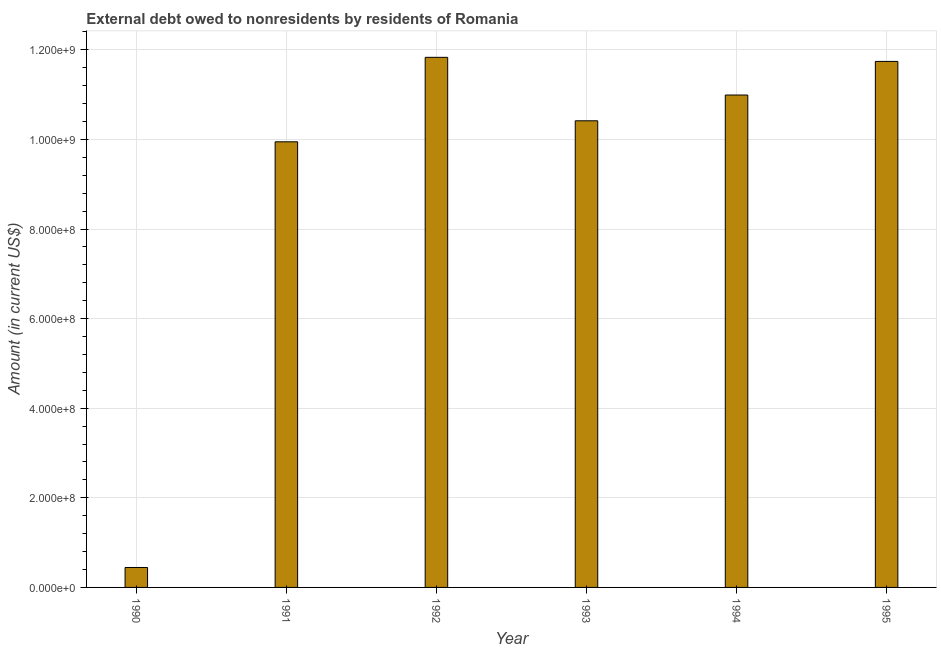Does the graph contain any zero values?
Ensure brevity in your answer.  No. What is the title of the graph?
Make the answer very short. External debt owed to nonresidents by residents of Romania. What is the label or title of the X-axis?
Provide a succinct answer. Year. What is the label or title of the Y-axis?
Keep it short and to the point. Amount (in current US$). What is the debt in 1992?
Offer a very short reply. 1.18e+09. Across all years, what is the maximum debt?
Make the answer very short. 1.18e+09. Across all years, what is the minimum debt?
Your answer should be compact. 4.45e+07. In which year was the debt minimum?
Offer a very short reply. 1990. What is the sum of the debt?
Offer a terse response. 5.54e+09. What is the difference between the debt in 1991 and 1995?
Provide a short and direct response. -1.79e+08. What is the average debt per year?
Ensure brevity in your answer.  9.23e+08. What is the median debt?
Keep it short and to the point. 1.07e+09. Do a majority of the years between 1992 and 1995 (inclusive) have debt greater than 280000000 US$?
Provide a short and direct response. Yes. What is the ratio of the debt in 1994 to that in 1995?
Your answer should be compact. 0.94. What is the difference between the highest and the second highest debt?
Give a very brief answer. 9.10e+06. Is the sum of the debt in 1990 and 1992 greater than the maximum debt across all years?
Make the answer very short. Yes. What is the difference between the highest and the lowest debt?
Keep it short and to the point. 1.14e+09. In how many years, is the debt greater than the average debt taken over all years?
Your response must be concise. 5. How many bars are there?
Make the answer very short. 6. Are all the bars in the graph horizontal?
Keep it short and to the point. No. Are the values on the major ticks of Y-axis written in scientific E-notation?
Offer a very short reply. Yes. What is the Amount (in current US$) in 1990?
Keep it short and to the point. 4.45e+07. What is the Amount (in current US$) in 1991?
Give a very brief answer. 9.95e+08. What is the Amount (in current US$) of 1992?
Make the answer very short. 1.18e+09. What is the Amount (in current US$) in 1993?
Offer a terse response. 1.04e+09. What is the Amount (in current US$) in 1994?
Your response must be concise. 1.10e+09. What is the Amount (in current US$) of 1995?
Offer a very short reply. 1.17e+09. What is the difference between the Amount (in current US$) in 1990 and 1991?
Your answer should be very brief. -9.50e+08. What is the difference between the Amount (in current US$) in 1990 and 1992?
Offer a very short reply. -1.14e+09. What is the difference between the Amount (in current US$) in 1990 and 1993?
Your answer should be compact. -9.97e+08. What is the difference between the Amount (in current US$) in 1990 and 1994?
Give a very brief answer. -1.05e+09. What is the difference between the Amount (in current US$) in 1990 and 1995?
Make the answer very short. -1.13e+09. What is the difference between the Amount (in current US$) in 1991 and 1992?
Keep it short and to the point. -1.89e+08. What is the difference between the Amount (in current US$) in 1991 and 1993?
Provide a succinct answer. -4.69e+07. What is the difference between the Amount (in current US$) in 1991 and 1994?
Offer a terse response. -1.04e+08. What is the difference between the Amount (in current US$) in 1991 and 1995?
Offer a very short reply. -1.79e+08. What is the difference between the Amount (in current US$) in 1992 and 1993?
Ensure brevity in your answer.  1.42e+08. What is the difference between the Amount (in current US$) in 1992 and 1994?
Give a very brief answer. 8.41e+07. What is the difference between the Amount (in current US$) in 1992 and 1995?
Your response must be concise. 9.10e+06. What is the difference between the Amount (in current US$) in 1993 and 1994?
Offer a very short reply. -5.75e+07. What is the difference between the Amount (in current US$) in 1993 and 1995?
Keep it short and to the point. -1.33e+08. What is the difference between the Amount (in current US$) in 1994 and 1995?
Provide a short and direct response. -7.50e+07. What is the ratio of the Amount (in current US$) in 1990 to that in 1991?
Provide a short and direct response. 0.04. What is the ratio of the Amount (in current US$) in 1990 to that in 1992?
Your answer should be very brief. 0.04. What is the ratio of the Amount (in current US$) in 1990 to that in 1993?
Make the answer very short. 0.04. What is the ratio of the Amount (in current US$) in 1990 to that in 1994?
Offer a very short reply. 0.04. What is the ratio of the Amount (in current US$) in 1990 to that in 1995?
Ensure brevity in your answer.  0.04. What is the ratio of the Amount (in current US$) in 1991 to that in 1992?
Your response must be concise. 0.84. What is the ratio of the Amount (in current US$) in 1991 to that in 1993?
Give a very brief answer. 0.95. What is the ratio of the Amount (in current US$) in 1991 to that in 1994?
Offer a terse response. 0.91. What is the ratio of the Amount (in current US$) in 1991 to that in 1995?
Your answer should be compact. 0.85. What is the ratio of the Amount (in current US$) in 1992 to that in 1993?
Your answer should be compact. 1.14. What is the ratio of the Amount (in current US$) in 1992 to that in 1994?
Your answer should be very brief. 1.08. What is the ratio of the Amount (in current US$) in 1993 to that in 1994?
Provide a succinct answer. 0.95. What is the ratio of the Amount (in current US$) in 1993 to that in 1995?
Provide a short and direct response. 0.89. What is the ratio of the Amount (in current US$) in 1994 to that in 1995?
Give a very brief answer. 0.94. 